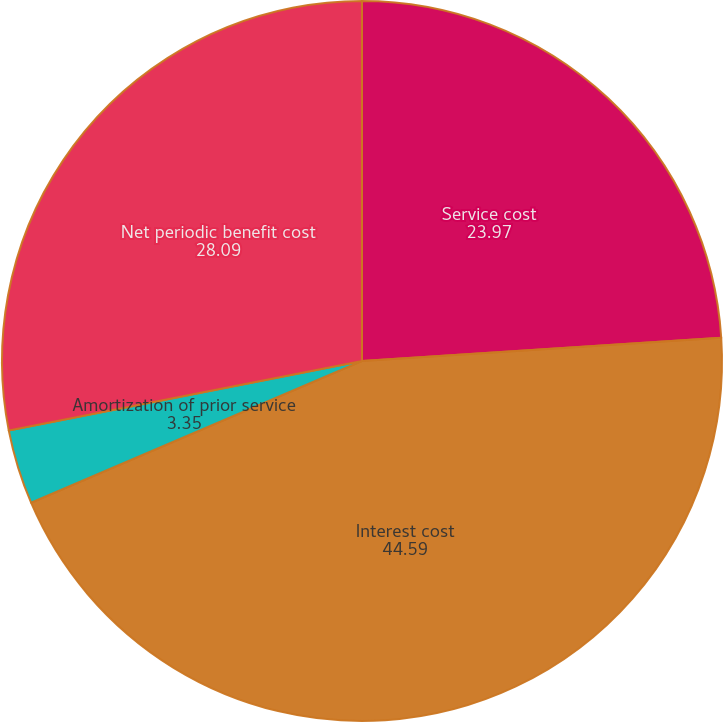<chart> <loc_0><loc_0><loc_500><loc_500><pie_chart><fcel>Service cost<fcel>Interest cost<fcel>Amortization of prior service<fcel>Net periodic benefit cost<nl><fcel>23.97%<fcel>44.59%<fcel>3.35%<fcel>28.09%<nl></chart> 